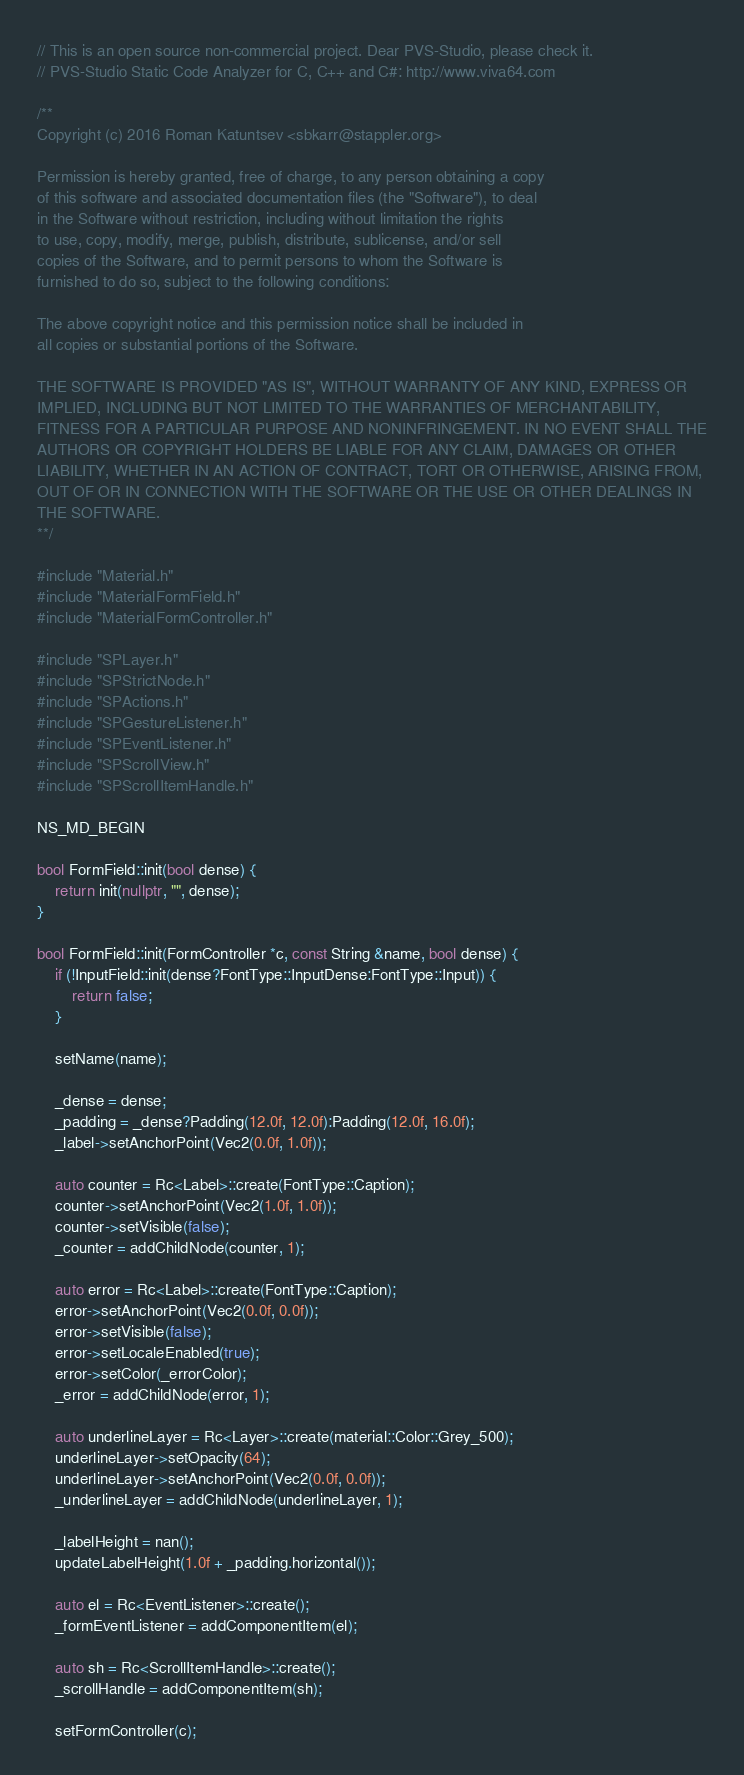Convert code to text. <code><loc_0><loc_0><loc_500><loc_500><_C++_>// This is an open source non-commercial project. Dear PVS-Studio, please check it.
// PVS-Studio Static Code Analyzer for C, C++ and C#: http://www.viva64.com

/**
Copyright (c) 2016 Roman Katuntsev <sbkarr@stappler.org>

Permission is hereby granted, free of charge, to any person obtaining a copy
of this software and associated documentation files (the "Software"), to deal
in the Software without restriction, including without limitation the rights
to use, copy, modify, merge, publish, distribute, sublicense, and/or sell
copies of the Software, and to permit persons to whom the Software is
furnished to do so, subject to the following conditions:

The above copyright notice and this permission notice shall be included in
all copies or substantial portions of the Software.

THE SOFTWARE IS PROVIDED "AS IS", WITHOUT WARRANTY OF ANY KIND, EXPRESS OR
IMPLIED, INCLUDING BUT NOT LIMITED TO THE WARRANTIES OF MERCHANTABILITY,
FITNESS FOR A PARTICULAR PURPOSE AND NONINFRINGEMENT. IN NO EVENT SHALL THE
AUTHORS OR COPYRIGHT HOLDERS BE LIABLE FOR ANY CLAIM, DAMAGES OR OTHER
LIABILITY, WHETHER IN AN ACTION OF CONTRACT, TORT OR OTHERWISE, ARISING FROM,
OUT OF OR IN CONNECTION WITH THE SOFTWARE OR THE USE OR OTHER DEALINGS IN
THE SOFTWARE.
**/

#include "Material.h"
#include "MaterialFormField.h"
#include "MaterialFormController.h"

#include "SPLayer.h"
#include "SPStrictNode.h"
#include "SPActions.h"
#include "SPGestureListener.h"
#include "SPEventListener.h"
#include "SPScrollView.h"
#include "SPScrollItemHandle.h"

NS_MD_BEGIN

bool FormField::init(bool dense) {
	return init(nullptr, "", dense);
}

bool FormField::init(FormController *c, const String &name, bool dense) {
	if (!InputField::init(dense?FontType::InputDense:FontType::Input)) {
		return false;
	}

	setName(name);

	_dense = dense;
	_padding = _dense?Padding(12.0f, 12.0f):Padding(12.0f, 16.0f);
	_label->setAnchorPoint(Vec2(0.0f, 1.0f));

	auto counter = Rc<Label>::create(FontType::Caption);
	counter->setAnchorPoint(Vec2(1.0f, 1.0f));
	counter->setVisible(false);
	_counter = addChildNode(counter, 1);

	auto error = Rc<Label>::create(FontType::Caption);
	error->setAnchorPoint(Vec2(0.0f, 0.0f));
	error->setVisible(false);
	error->setLocaleEnabled(true);
	error->setColor(_errorColor);
	_error = addChildNode(error, 1);

	auto underlineLayer = Rc<Layer>::create(material::Color::Grey_500);
	underlineLayer->setOpacity(64);
	underlineLayer->setAnchorPoint(Vec2(0.0f, 0.0f));
	_underlineLayer = addChildNode(underlineLayer, 1);

	_labelHeight = nan();
	updateLabelHeight(1.0f + _padding.horizontal());

	auto el = Rc<EventListener>::create();
	_formEventListener = addComponentItem(el);

	auto sh = Rc<ScrollItemHandle>::create();
	_scrollHandle = addComponentItem(sh);

	setFormController(c);
</code> 